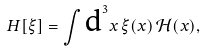<formula> <loc_0><loc_0><loc_500><loc_500>H [ \xi ] = \int \text {d} ^ { 3 } x \, \xi ( x ) \, { \mathcal { H } } ( x ) ,</formula> 